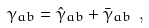Convert formula to latex. <formula><loc_0><loc_0><loc_500><loc_500>\gamma _ { a b } = \hat { \gamma } _ { a b } + \bar { \gamma } _ { a b } \ ,</formula> 